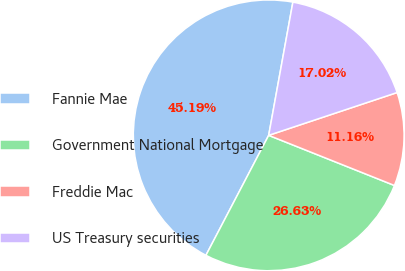Convert chart to OTSL. <chart><loc_0><loc_0><loc_500><loc_500><pie_chart><fcel>Fannie Mae<fcel>Government National Mortgage<fcel>Freddie Mac<fcel>US Treasury securities<nl><fcel>45.19%<fcel>26.63%<fcel>11.16%<fcel>17.02%<nl></chart> 